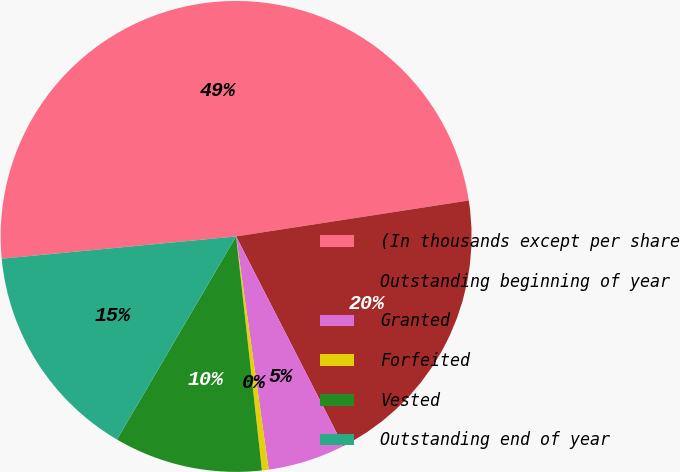Convert chart to OTSL. <chart><loc_0><loc_0><loc_500><loc_500><pie_chart><fcel>(In thousands except per share<fcel>Outstanding beginning of year<fcel>Granted<fcel>Forfeited<fcel>Vested<fcel>Outstanding end of year<nl><fcel>49.07%<fcel>19.91%<fcel>5.32%<fcel>0.46%<fcel>10.19%<fcel>15.05%<nl></chart> 